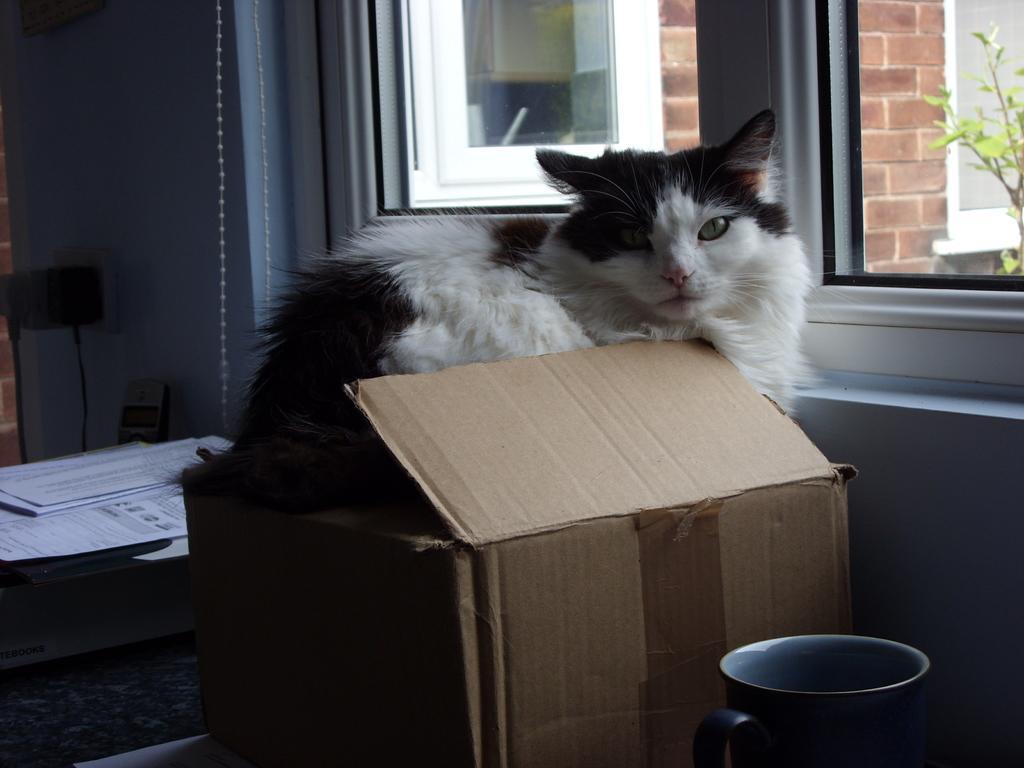Describe this image in one or two sentences. In this image I can see cartoon box, a mug, windows, a plant, few papers and a cat. On these papers I can see something is written. I can see color of this cat is black and white. 